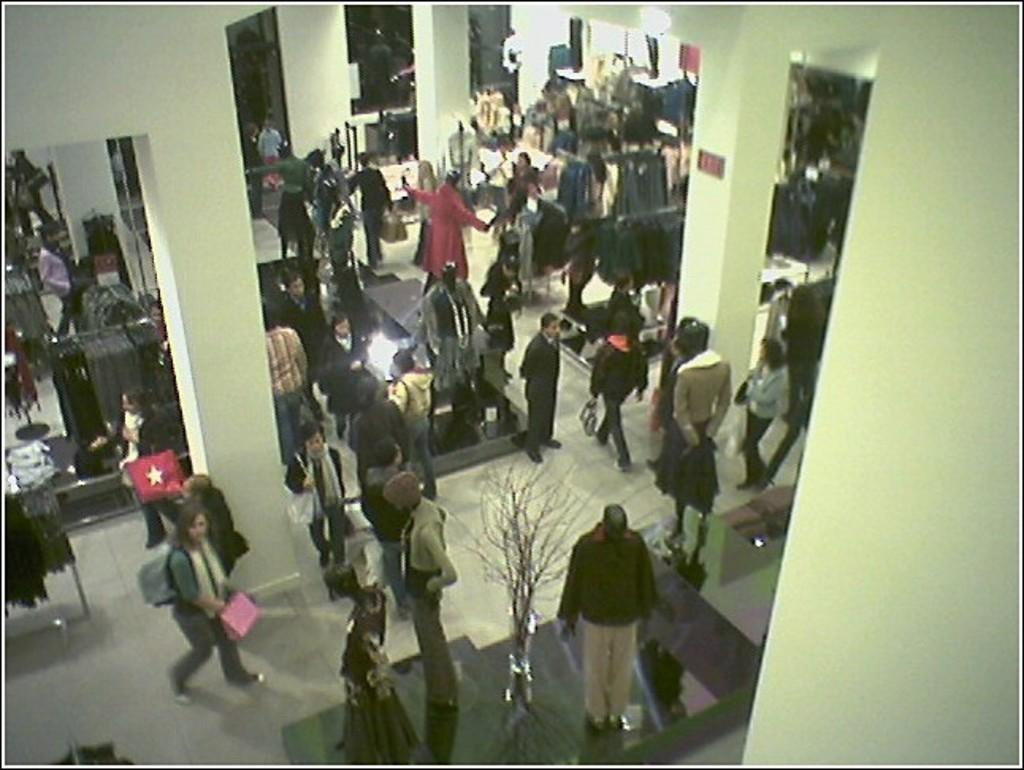What types of living organisms can be seen in the image? People can be seen in the image. What architectural features are present in the image? Pillars are present in the image. What inanimate objects are in the image? Mannequins, clothes, a vase, a board, and a floor are in the image. What type of lighting is present in the image? There is light in the image. What structural elements can be seen in the image? Walls are visible in the image. Can you see a monkey playing with the clothes on the stage in the image? There is no monkey or stage present in the image. Are the people in the image crying? The provided facts do not mention any emotions or actions of the people in the image, so it cannot be determined if they are crying. 